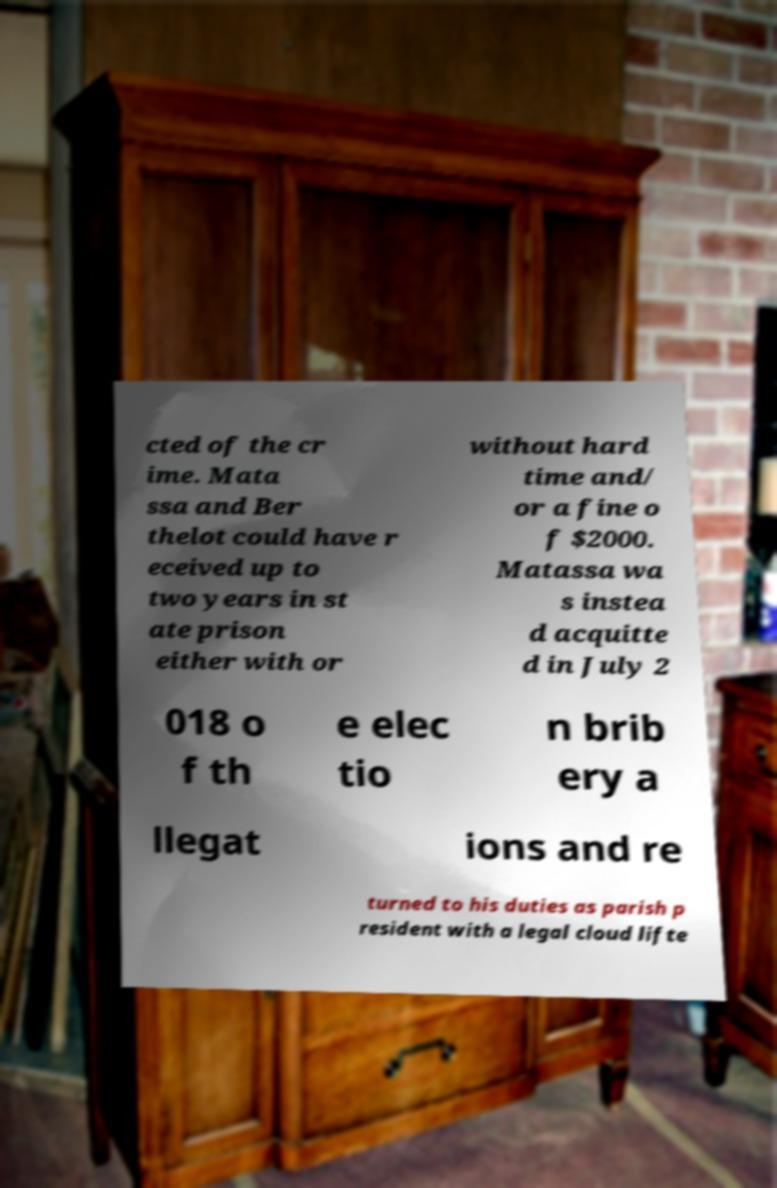What messages or text are displayed in this image? I need them in a readable, typed format. cted of the cr ime. Mata ssa and Ber thelot could have r eceived up to two years in st ate prison either with or without hard time and/ or a fine o f $2000. Matassa wa s instea d acquitte d in July 2 018 o f th e elec tio n brib ery a llegat ions and re turned to his duties as parish p resident with a legal cloud lifte 